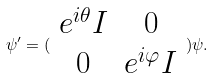<formula> <loc_0><loc_0><loc_500><loc_500>\psi ^ { \prime } = ( \begin{array} { c c } e ^ { i \theta } I & 0 \\ 0 & e ^ { i \varphi } I \end{array} ) \psi .</formula> 